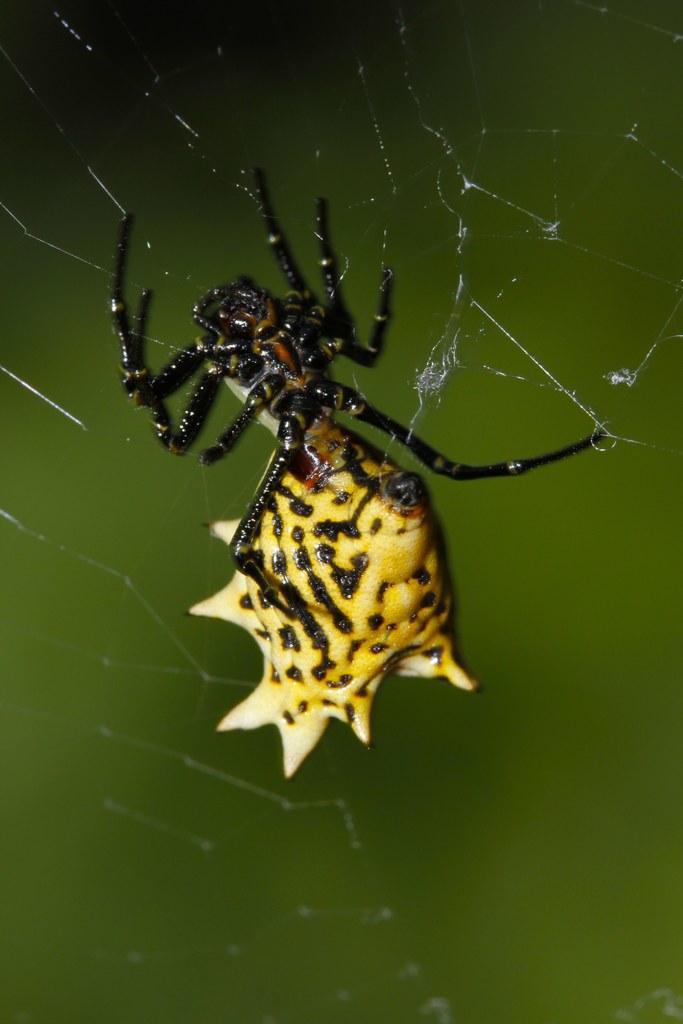Can you describe this image briefly? In this image in the center there is one spider and a net. 